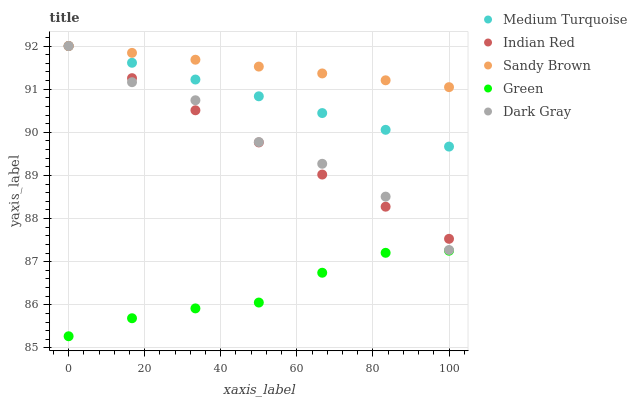Does Green have the minimum area under the curve?
Answer yes or no. Yes. Does Sandy Brown have the maximum area under the curve?
Answer yes or no. Yes. Does Sandy Brown have the minimum area under the curve?
Answer yes or no. No. Does Green have the maximum area under the curve?
Answer yes or no. No. Is Sandy Brown the smoothest?
Answer yes or no. Yes. Is Dark Gray the roughest?
Answer yes or no. Yes. Is Green the smoothest?
Answer yes or no. No. Is Green the roughest?
Answer yes or no. No. Does Green have the lowest value?
Answer yes or no. Yes. Does Sandy Brown have the lowest value?
Answer yes or no. No. Does Medium Turquoise have the highest value?
Answer yes or no. Yes. Does Green have the highest value?
Answer yes or no. No. Is Green less than Dark Gray?
Answer yes or no. Yes. Is Indian Red greater than Green?
Answer yes or no. Yes. Does Indian Red intersect Dark Gray?
Answer yes or no. Yes. Is Indian Red less than Dark Gray?
Answer yes or no. No. Is Indian Red greater than Dark Gray?
Answer yes or no. No. Does Green intersect Dark Gray?
Answer yes or no. No. 